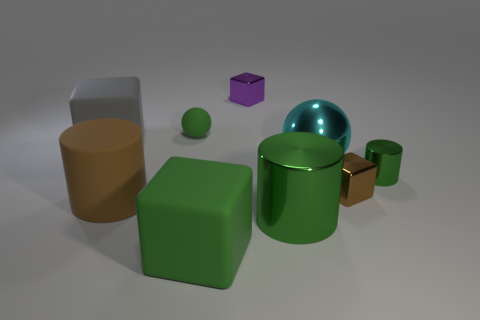There is a small metal object that is behind the tiny green thing that is right of the large block right of the rubber cylinder; what shape is it?
Ensure brevity in your answer.  Cube. There is a shiny thing that is behind the small green metal thing and in front of the big gray cube; what is its size?
Your answer should be compact. Large. What number of small shiny things are the same color as the small matte thing?
Provide a short and direct response. 1. What material is the big cube that is the same color as the small ball?
Provide a short and direct response. Rubber. What is the large brown thing made of?
Keep it short and to the point. Rubber. Does the big cube in front of the large gray block have the same material as the green ball?
Give a very brief answer. Yes. The rubber object that is behind the gray block has what shape?
Give a very brief answer. Sphere. What material is the other block that is the same size as the green block?
Keep it short and to the point. Rubber. How many objects are either blocks that are to the right of the small purple block or small metal blocks right of the large ball?
Your answer should be very brief. 1. The cyan ball that is the same material as the small purple block is what size?
Provide a short and direct response. Large. 